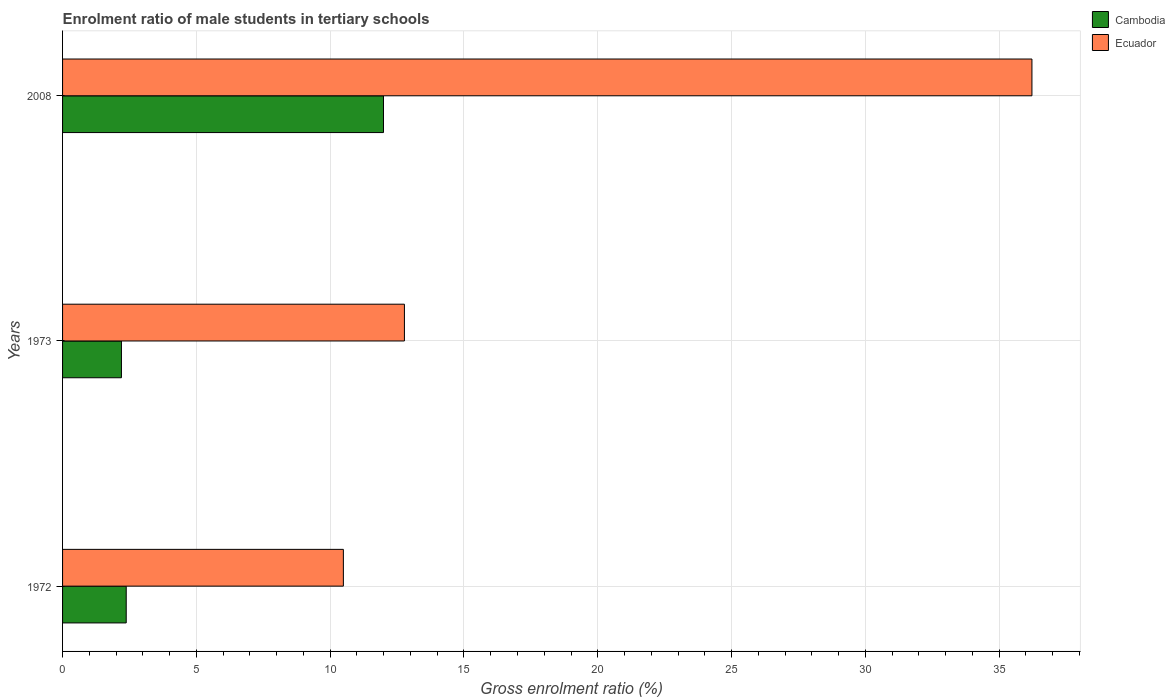How many groups of bars are there?
Your answer should be compact. 3. Are the number of bars per tick equal to the number of legend labels?
Provide a short and direct response. Yes. Are the number of bars on each tick of the Y-axis equal?
Your answer should be compact. Yes. How many bars are there on the 3rd tick from the bottom?
Offer a very short reply. 2. In how many cases, is the number of bars for a given year not equal to the number of legend labels?
Offer a very short reply. 0. What is the enrolment ratio of male students in tertiary schools in Ecuador in 1972?
Make the answer very short. 10.49. Across all years, what is the maximum enrolment ratio of male students in tertiary schools in Cambodia?
Ensure brevity in your answer.  11.99. Across all years, what is the minimum enrolment ratio of male students in tertiary schools in Cambodia?
Your answer should be compact. 2.2. What is the total enrolment ratio of male students in tertiary schools in Cambodia in the graph?
Give a very brief answer. 16.57. What is the difference between the enrolment ratio of male students in tertiary schools in Cambodia in 1972 and that in 1973?
Make the answer very short. 0.18. What is the difference between the enrolment ratio of male students in tertiary schools in Cambodia in 2008 and the enrolment ratio of male students in tertiary schools in Ecuador in 1972?
Provide a succinct answer. 1.5. What is the average enrolment ratio of male students in tertiary schools in Cambodia per year?
Provide a short and direct response. 5.52. In the year 2008, what is the difference between the enrolment ratio of male students in tertiary schools in Ecuador and enrolment ratio of male students in tertiary schools in Cambodia?
Your response must be concise. 24.23. In how many years, is the enrolment ratio of male students in tertiary schools in Ecuador greater than 23 %?
Give a very brief answer. 1. What is the ratio of the enrolment ratio of male students in tertiary schools in Cambodia in 1973 to that in 2008?
Offer a very short reply. 0.18. Is the enrolment ratio of male students in tertiary schools in Ecuador in 1973 less than that in 2008?
Your answer should be compact. Yes. Is the difference between the enrolment ratio of male students in tertiary schools in Ecuador in 1972 and 1973 greater than the difference between the enrolment ratio of male students in tertiary schools in Cambodia in 1972 and 1973?
Provide a succinct answer. No. What is the difference between the highest and the second highest enrolment ratio of male students in tertiary schools in Cambodia?
Give a very brief answer. 9.61. What is the difference between the highest and the lowest enrolment ratio of male students in tertiary schools in Cambodia?
Provide a short and direct response. 9.79. Is the sum of the enrolment ratio of male students in tertiary schools in Ecuador in 1973 and 2008 greater than the maximum enrolment ratio of male students in tertiary schools in Cambodia across all years?
Your answer should be very brief. Yes. What does the 2nd bar from the top in 2008 represents?
Provide a succinct answer. Cambodia. What does the 1st bar from the bottom in 1973 represents?
Ensure brevity in your answer.  Cambodia. Are all the bars in the graph horizontal?
Offer a very short reply. Yes. How many years are there in the graph?
Ensure brevity in your answer.  3. What is the difference between two consecutive major ticks on the X-axis?
Provide a succinct answer. 5. What is the title of the graph?
Make the answer very short. Enrolment ratio of male students in tertiary schools. Does "Ethiopia" appear as one of the legend labels in the graph?
Give a very brief answer. No. What is the label or title of the Y-axis?
Give a very brief answer. Years. What is the Gross enrolment ratio (%) in Cambodia in 1972?
Your response must be concise. 2.38. What is the Gross enrolment ratio (%) in Ecuador in 1972?
Give a very brief answer. 10.49. What is the Gross enrolment ratio (%) in Cambodia in 1973?
Offer a terse response. 2.2. What is the Gross enrolment ratio (%) of Ecuador in 1973?
Your answer should be compact. 12.77. What is the Gross enrolment ratio (%) in Cambodia in 2008?
Provide a succinct answer. 11.99. What is the Gross enrolment ratio (%) in Ecuador in 2008?
Your response must be concise. 36.22. Across all years, what is the maximum Gross enrolment ratio (%) of Cambodia?
Provide a succinct answer. 11.99. Across all years, what is the maximum Gross enrolment ratio (%) of Ecuador?
Keep it short and to the point. 36.22. Across all years, what is the minimum Gross enrolment ratio (%) of Cambodia?
Offer a terse response. 2.2. Across all years, what is the minimum Gross enrolment ratio (%) in Ecuador?
Your response must be concise. 10.49. What is the total Gross enrolment ratio (%) in Cambodia in the graph?
Offer a terse response. 16.57. What is the total Gross enrolment ratio (%) in Ecuador in the graph?
Offer a terse response. 59.49. What is the difference between the Gross enrolment ratio (%) in Cambodia in 1972 and that in 1973?
Keep it short and to the point. 0.18. What is the difference between the Gross enrolment ratio (%) of Ecuador in 1972 and that in 1973?
Your answer should be compact. -2.28. What is the difference between the Gross enrolment ratio (%) in Cambodia in 1972 and that in 2008?
Offer a very short reply. -9.61. What is the difference between the Gross enrolment ratio (%) in Ecuador in 1972 and that in 2008?
Keep it short and to the point. -25.73. What is the difference between the Gross enrolment ratio (%) in Cambodia in 1973 and that in 2008?
Provide a succinct answer. -9.79. What is the difference between the Gross enrolment ratio (%) in Ecuador in 1973 and that in 2008?
Offer a very short reply. -23.45. What is the difference between the Gross enrolment ratio (%) in Cambodia in 1972 and the Gross enrolment ratio (%) in Ecuador in 1973?
Your response must be concise. -10.4. What is the difference between the Gross enrolment ratio (%) of Cambodia in 1972 and the Gross enrolment ratio (%) of Ecuador in 2008?
Your answer should be compact. -33.85. What is the difference between the Gross enrolment ratio (%) of Cambodia in 1973 and the Gross enrolment ratio (%) of Ecuador in 2008?
Provide a short and direct response. -34.02. What is the average Gross enrolment ratio (%) of Cambodia per year?
Your response must be concise. 5.52. What is the average Gross enrolment ratio (%) of Ecuador per year?
Provide a succinct answer. 19.83. In the year 1972, what is the difference between the Gross enrolment ratio (%) of Cambodia and Gross enrolment ratio (%) of Ecuador?
Your answer should be compact. -8.11. In the year 1973, what is the difference between the Gross enrolment ratio (%) of Cambodia and Gross enrolment ratio (%) of Ecuador?
Make the answer very short. -10.57. In the year 2008, what is the difference between the Gross enrolment ratio (%) of Cambodia and Gross enrolment ratio (%) of Ecuador?
Keep it short and to the point. -24.23. What is the ratio of the Gross enrolment ratio (%) in Cambodia in 1972 to that in 1973?
Ensure brevity in your answer.  1.08. What is the ratio of the Gross enrolment ratio (%) of Ecuador in 1972 to that in 1973?
Provide a short and direct response. 0.82. What is the ratio of the Gross enrolment ratio (%) of Cambodia in 1972 to that in 2008?
Provide a short and direct response. 0.2. What is the ratio of the Gross enrolment ratio (%) in Ecuador in 1972 to that in 2008?
Offer a very short reply. 0.29. What is the ratio of the Gross enrolment ratio (%) of Cambodia in 1973 to that in 2008?
Provide a short and direct response. 0.18. What is the ratio of the Gross enrolment ratio (%) of Ecuador in 1973 to that in 2008?
Your answer should be very brief. 0.35. What is the difference between the highest and the second highest Gross enrolment ratio (%) in Cambodia?
Offer a terse response. 9.61. What is the difference between the highest and the second highest Gross enrolment ratio (%) of Ecuador?
Keep it short and to the point. 23.45. What is the difference between the highest and the lowest Gross enrolment ratio (%) of Cambodia?
Ensure brevity in your answer.  9.79. What is the difference between the highest and the lowest Gross enrolment ratio (%) of Ecuador?
Your answer should be very brief. 25.73. 